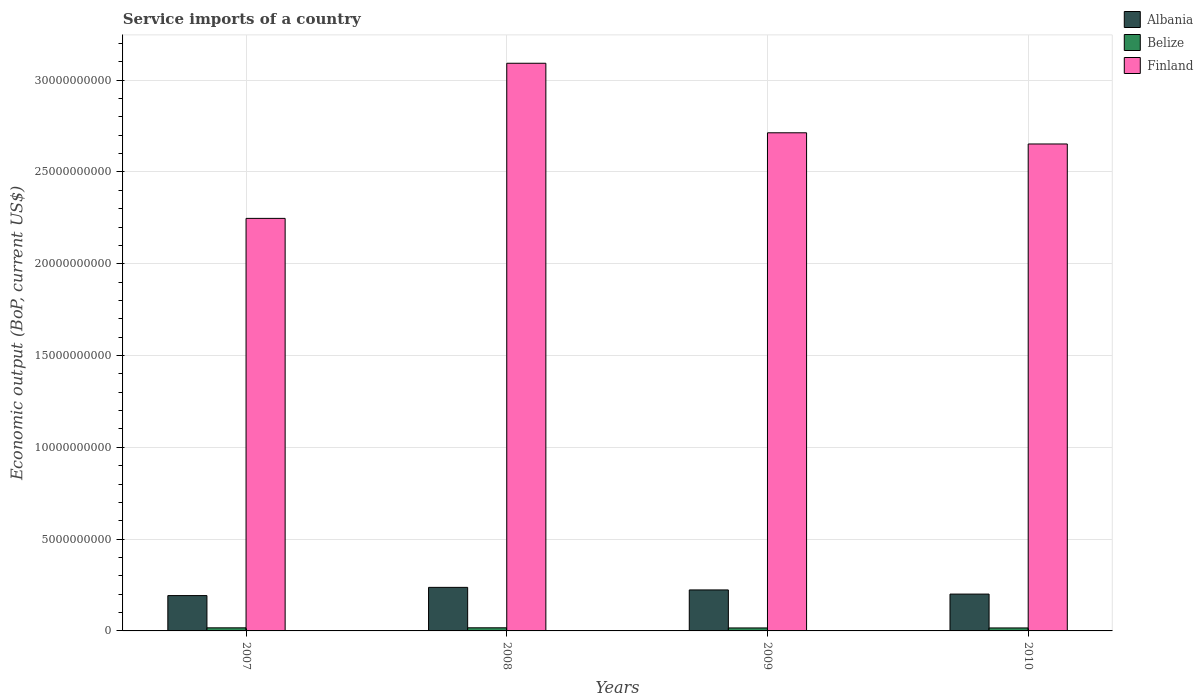How many bars are there on the 2nd tick from the left?
Ensure brevity in your answer.  3. How many bars are there on the 3rd tick from the right?
Your response must be concise. 3. What is the label of the 4th group of bars from the left?
Offer a very short reply. 2010. In how many cases, is the number of bars for a given year not equal to the number of legend labels?
Your response must be concise. 0. What is the service imports in Finland in 2008?
Your response must be concise. 3.09e+1. Across all years, what is the maximum service imports in Albania?
Give a very brief answer. 2.37e+09. Across all years, what is the minimum service imports in Finland?
Offer a very short reply. 2.25e+1. In which year was the service imports in Belize maximum?
Provide a short and direct response. 2008. In which year was the service imports in Finland minimum?
Provide a succinct answer. 2007. What is the total service imports in Belize in the graph?
Offer a very short reply. 6.62e+08. What is the difference between the service imports in Finland in 2007 and that in 2008?
Your response must be concise. -8.45e+09. What is the difference between the service imports in Finland in 2008 and the service imports in Albania in 2009?
Keep it short and to the point. 2.87e+1. What is the average service imports in Albania per year?
Provide a short and direct response. 2.13e+09. In the year 2010, what is the difference between the service imports in Albania and service imports in Belize?
Offer a terse response. 1.84e+09. What is the ratio of the service imports in Albania in 2007 to that in 2010?
Keep it short and to the point. 0.96. Is the service imports in Finland in 2007 less than that in 2010?
Provide a short and direct response. Yes. Is the difference between the service imports in Albania in 2007 and 2010 greater than the difference between the service imports in Belize in 2007 and 2010?
Your answer should be compact. No. What is the difference between the highest and the second highest service imports in Finland?
Give a very brief answer. 3.79e+09. What is the difference between the highest and the lowest service imports in Finland?
Your answer should be compact. 8.45e+09. In how many years, is the service imports in Belize greater than the average service imports in Belize taken over all years?
Give a very brief answer. 2. What does the 2nd bar from the left in 2009 represents?
Your answer should be very brief. Belize. What does the 3rd bar from the right in 2010 represents?
Keep it short and to the point. Albania. How many bars are there?
Keep it short and to the point. 12. Does the graph contain grids?
Make the answer very short. Yes. How are the legend labels stacked?
Keep it short and to the point. Vertical. What is the title of the graph?
Offer a very short reply. Service imports of a country. Does "Middle East & North Africa (developing only)" appear as one of the legend labels in the graph?
Make the answer very short. No. What is the label or title of the Y-axis?
Ensure brevity in your answer.  Economic output (BoP, current US$). What is the Economic output (BoP, current US$) of Albania in 2007?
Your answer should be compact. 1.92e+09. What is the Economic output (BoP, current US$) of Belize in 2007?
Your response must be concise. 1.68e+08. What is the Economic output (BoP, current US$) in Finland in 2007?
Ensure brevity in your answer.  2.25e+1. What is the Economic output (BoP, current US$) in Albania in 2008?
Provide a short and direct response. 2.37e+09. What is the Economic output (BoP, current US$) in Belize in 2008?
Your answer should be very brief. 1.70e+08. What is the Economic output (BoP, current US$) in Finland in 2008?
Provide a succinct answer. 3.09e+1. What is the Economic output (BoP, current US$) in Albania in 2009?
Ensure brevity in your answer.  2.23e+09. What is the Economic output (BoP, current US$) in Belize in 2009?
Offer a terse response. 1.62e+08. What is the Economic output (BoP, current US$) of Finland in 2009?
Give a very brief answer. 2.71e+1. What is the Economic output (BoP, current US$) in Albania in 2010?
Keep it short and to the point. 2.01e+09. What is the Economic output (BoP, current US$) in Belize in 2010?
Your answer should be very brief. 1.62e+08. What is the Economic output (BoP, current US$) in Finland in 2010?
Your answer should be compact. 2.65e+1. Across all years, what is the maximum Economic output (BoP, current US$) of Albania?
Provide a short and direct response. 2.37e+09. Across all years, what is the maximum Economic output (BoP, current US$) of Belize?
Make the answer very short. 1.70e+08. Across all years, what is the maximum Economic output (BoP, current US$) of Finland?
Make the answer very short. 3.09e+1. Across all years, what is the minimum Economic output (BoP, current US$) in Albania?
Your answer should be compact. 1.92e+09. Across all years, what is the minimum Economic output (BoP, current US$) in Belize?
Provide a succinct answer. 1.62e+08. Across all years, what is the minimum Economic output (BoP, current US$) of Finland?
Keep it short and to the point. 2.25e+1. What is the total Economic output (BoP, current US$) of Albania in the graph?
Give a very brief answer. 8.54e+09. What is the total Economic output (BoP, current US$) of Belize in the graph?
Provide a succinct answer. 6.62e+08. What is the total Economic output (BoP, current US$) of Finland in the graph?
Provide a short and direct response. 1.07e+11. What is the difference between the Economic output (BoP, current US$) in Albania in 2007 and that in 2008?
Give a very brief answer. -4.48e+08. What is the difference between the Economic output (BoP, current US$) of Belize in 2007 and that in 2008?
Keep it short and to the point. -1.42e+06. What is the difference between the Economic output (BoP, current US$) of Finland in 2007 and that in 2008?
Provide a succinct answer. -8.45e+09. What is the difference between the Economic output (BoP, current US$) in Albania in 2007 and that in 2009?
Your answer should be compact. -3.08e+08. What is the difference between the Economic output (BoP, current US$) of Belize in 2007 and that in 2009?
Keep it short and to the point. 6.41e+06. What is the difference between the Economic output (BoP, current US$) in Finland in 2007 and that in 2009?
Provide a short and direct response. -4.66e+09. What is the difference between the Economic output (BoP, current US$) of Albania in 2007 and that in 2010?
Your answer should be very brief. -8.23e+07. What is the difference between the Economic output (BoP, current US$) of Belize in 2007 and that in 2010?
Your answer should be compact. 5.77e+06. What is the difference between the Economic output (BoP, current US$) of Finland in 2007 and that in 2010?
Give a very brief answer. -4.05e+09. What is the difference between the Economic output (BoP, current US$) of Albania in 2008 and that in 2009?
Your answer should be compact. 1.40e+08. What is the difference between the Economic output (BoP, current US$) of Belize in 2008 and that in 2009?
Provide a short and direct response. 7.83e+06. What is the difference between the Economic output (BoP, current US$) of Finland in 2008 and that in 2009?
Make the answer very short. 3.79e+09. What is the difference between the Economic output (BoP, current US$) of Albania in 2008 and that in 2010?
Give a very brief answer. 3.65e+08. What is the difference between the Economic output (BoP, current US$) of Belize in 2008 and that in 2010?
Make the answer very short. 7.18e+06. What is the difference between the Economic output (BoP, current US$) in Finland in 2008 and that in 2010?
Your answer should be compact. 4.40e+09. What is the difference between the Economic output (BoP, current US$) in Albania in 2009 and that in 2010?
Give a very brief answer. 2.26e+08. What is the difference between the Economic output (BoP, current US$) in Belize in 2009 and that in 2010?
Keep it short and to the point. -6.44e+05. What is the difference between the Economic output (BoP, current US$) in Finland in 2009 and that in 2010?
Provide a short and direct response. 6.09e+08. What is the difference between the Economic output (BoP, current US$) in Albania in 2007 and the Economic output (BoP, current US$) in Belize in 2008?
Offer a very short reply. 1.75e+09. What is the difference between the Economic output (BoP, current US$) in Albania in 2007 and the Economic output (BoP, current US$) in Finland in 2008?
Offer a terse response. -2.90e+1. What is the difference between the Economic output (BoP, current US$) of Belize in 2007 and the Economic output (BoP, current US$) of Finland in 2008?
Provide a short and direct response. -3.08e+1. What is the difference between the Economic output (BoP, current US$) of Albania in 2007 and the Economic output (BoP, current US$) of Belize in 2009?
Your response must be concise. 1.76e+09. What is the difference between the Economic output (BoP, current US$) in Albania in 2007 and the Economic output (BoP, current US$) in Finland in 2009?
Make the answer very short. -2.52e+1. What is the difference between the Economic output (BoP, current US$) in Belize in 2007 and the Economic output (BoP, current US$) in Finland in 2009?
Your answer should be compact. -2.70e+1. What is the difference between the Economic output (BoP, current US$) of Albania in 2007 and the Economic output (BoP, current US$) of Belize in 2010?
Provide a short and direct response. 1.76e+09. What is the difference between the Economic output (BoP, current US$) of Albania in 2007 and the Economic output (BoP, current US$) of Finland in 2010?
Keep it short and to the point. -2.46e+1. What is the difference between the Economic output (BoP, current US$) of Belize in 2007 and the Economic output (BoP, current US$) of Finland in 2010?
Provide a short and direct response. -2.64e+1. What is the difference between the Economic output (BoP, current US$) in Albania in 2008 and the Economic output (BoP, current US$) in Belize in 2009?
Provide a short and direct response. 2.21e+09. What is the difference between the Economic output (BoP, current US$) of Albania in 2008 and the Economic output (BoP, current US$) of Finland in 2009?
Give a very brief answer. -2.48e+1. What is the difference between the Economic output (BoP, current US$) in Belize in 2008 and the Economic output (BoP, current US$) in Finland in 2009?
Offer a terse response. -2.70e+1. What is the difference between the Economic output (BoP, current US$) of Albania in 2008 and the Economic output (BoP, current US$) of Belize in 2010?
Keep it short and to the point. 2.21e+09. What is the difference between the Economic output (BoP, current US$) in Albania in 2008 and the Economic output (BoP, current US$) in Finland in 2010?
Offer a very short reply. -2.42e+1. What is the difference between the Economic output (BoP, current US$) of Belize in 2008 and the Economic output (BoP, current US$) of Finland in 2010?
Your response must be concise. -2.64e+1. What is the difference between the Economic output (BoP, current US$) in Albania in 2009 and the Economic output (BoP, current US$) in Belize in 2010?
Offer a terse response. 2.07e+09. What is the difference between the Economic output (BoP, current US$) of Albania in 2009 and the Economic output (BoP, current US$) of Finland in 2010?
Provide a short and direct response. -2.43e+1. What is the difference between the Economic output (BoP, current US$) of Belize in 2009 and the Economic output (BoP, current US$) of Finland in 2010?
Make the answer very short. -2.64e+1. What is the average Economic output (BoP, current US$) in Albania per year?
Make the answer very short. 2.13e+09. What is the average Economic output (BoP, current US$) of Belize per year?
Provide a short and direct response. 1.65e+08. What is the average Economic output (BoP, current US$) of Finland per year?
Offer a terse response. 2.68e+1. In the year 2007, what is the difference between the Economic output (BoP, current US$) in Albania and Economic output (BoP, current US$) in Belize?
Offer a very short reply. 1.76e+09. In the year 2007, what is the difference between the Economic output (BoP, current US$) in Albania and Economic output (BoP, current US$) in Finland?
Ensure brevity in your answer.  -2.05e+1. In the year 2007, what is the difference between the Economic output (BoP, current US$) of Belize and Economic output (BoP, current US$) of Finland?
Offer a terse response. -2.23e+1. In the year 2008, what is the difference between the Economic output (BoP, current US$) of Albania and Economic output (BoP, current US$) of Belize?
Offer a very short reply. 2.20e+09. In the year 2008, what is the difference between the Economic output (BoP, current US$) of Albania and Economic output (BoP, current US$) of Finland?
Your answer should be very brief. -2.85e+1. In the year 2008, what is the difference between the Economic output (BoP, current US$) of Belize and Economic output (BoP, current US$) of Finland?
Your answer should be compact. -3.08e+1. In the year 2009, what is the difference between the Economic output (BoP, current US$) of Albania and Economic output (BoP, current US$) of Belize?
Your answer should be compact. 2.07e+09. In the year 2009, what is the difference between the Economic output (BoP, current US$) of Albania and Economic output (BoP, current US$) of Finland?
Keep it short and to the point. -2.49e+1. In the year 2009, what is the difference between the Economic output (BoP, current US$) of Belize and Economic output (BoP, current US$) of Finland?
Give a very brief answer. -2.70e+1. In the year 2010, what is the difference between the Economic output (BoP, current US$) in Albania and Economic output (BoP, current US$) in Belize?
Make the answer very short. 1.84e+09. In the year 2010, what is the difference between the Economic output (BoP, current US$) of Albania and Economic output (BoP, current US$) of Finland?
Give a very brief answer. -2.45e+1. In the year 2010, what is the difference between the Economic output (BoP, current US$) in Belize and Economic output (BoP, current US$) in Finland?
Offer a very short reply. -2.64e+1. What is the ratio of the Economic output (BoP, current US$) in Albania in 2007 to that in 2008?
Your answer should be compact. 0.81. What is the ratio of the Economic output (BoP, current US$) of Finland in 2007 to that in 2008?
Provide a succinct answer. 0.73. What is the ratio of the Economic output (BoP, current US$) of Albania in 2007 to that in 2009?
Make the answer very short. 0.86. What is the ratio of the Economic output (BoP, current US$) of Belize in 2007 to that in 2009?
Give a very brief answer. 1.04. What is the ratio of the Economic output (BoP, current US$) in Finland in 2007 to that in 2009?
Provide a short and direct response. 0.83. What is the ratio of the Economic output (BoP, current US$) in Albania in 2007 to that in 2010?
Ensure brevity in your answer.  0.96. What is the ratio of the Economic output (BoP, current US$) of Belize in 2007 to that in 2010?
Give a very brief answer. 1.04. What is the ratio of the Economic output (BoP, current US$) of Finland in 2007 to that in 2010?
Offer a very short reply. 0.85. What is the ratio of the Economic output (BoP, current US$) in Albania in 2008 to that in 2009?
Offer a very short reply. 1.06. What is the ratio of the Economic output (BoP, current US$) of Belize in 2008 to that in 2009?
Give a very brief answer. 1.05. What is the ratio of the Economic output (BoP, current US$) of Finland in 2008 to that in 2009?
Provide a succinct answer. 1.14. What is the ratio of the Economic output (BoP, current US$) of Albania in 2008 to that in 2010?
Give a very brief answer. 1.18. What is the ratio of the Economic output (BoP, current US$) in Belize in 2008 to that in 2010?
Ensure brevity in your answer.  1.04. What is the ratio of the Economic output (BoP, current US$) of Finland in 2008 to that in 2010?
Your answer should be compact. 1.17. What is the ratio of the Economic output (BoP, current US$) of Albania in 2009 to that in 2010?
Give a very brief answer. 1.11. What is the ratio of the Economic output (BoP, current US$) in Belize in 2009 to that in 2010?
Provide a short and direct response. 1. What is the difference between the highest and the second highest Economic output (BoP, current US$) of Albania?
Provide a short and direct response. 1.40e+08. What is the difference between the highest and the second highest Economic output (BoP, current US$) of Belize?
Your answer should be compact. 1.42e+06. What is the difference between the highest and the second highest Economic output (BoP, current US$) in Finland?
Offer a terse response. 3.79e+09. What is the difference between the highest and the lowest Economic output (BoP, current US$) of Albania?
Keep it short and to the point. 4.48e+08. What is the difference between the highest and the lowest Economic output (BoP, current US$) of Belize?
Your answer should be very brief. 7.83e+06. What is the difference between the highest and the lowest Economic output (BoP, current US$) of Finland?
Your answer should be very brief. 8.45e+09. 